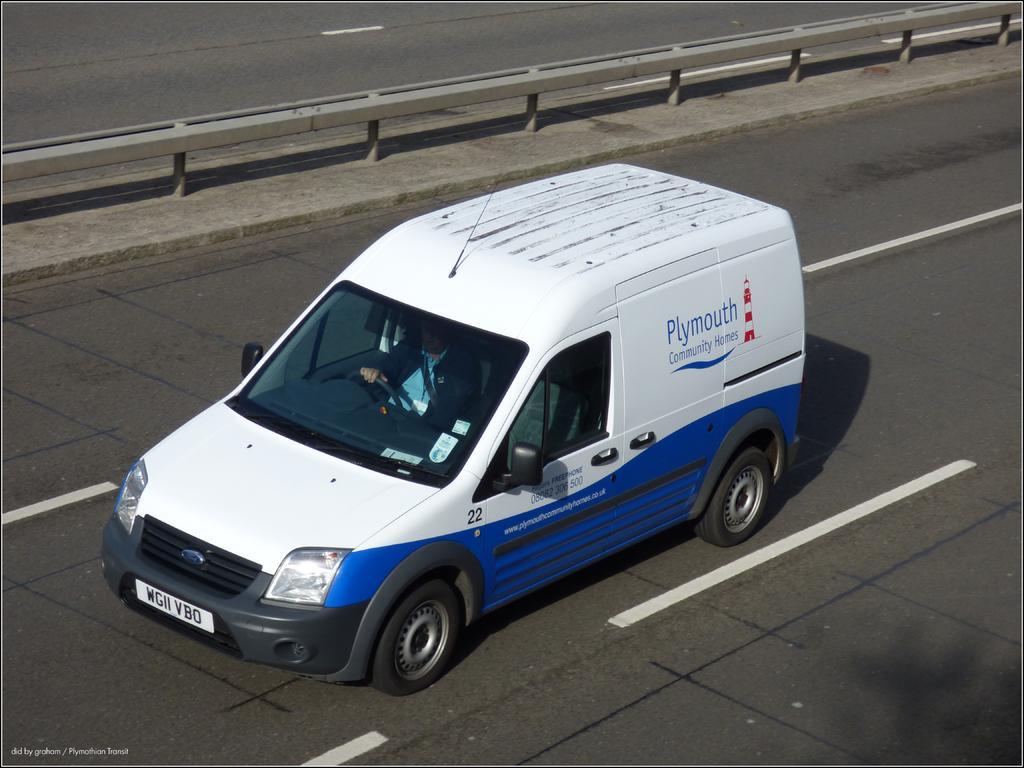In one or two sentences, can you explain what this image depicts? In this picture we can observe a white color car moving on this road. We can observe a divider here. 